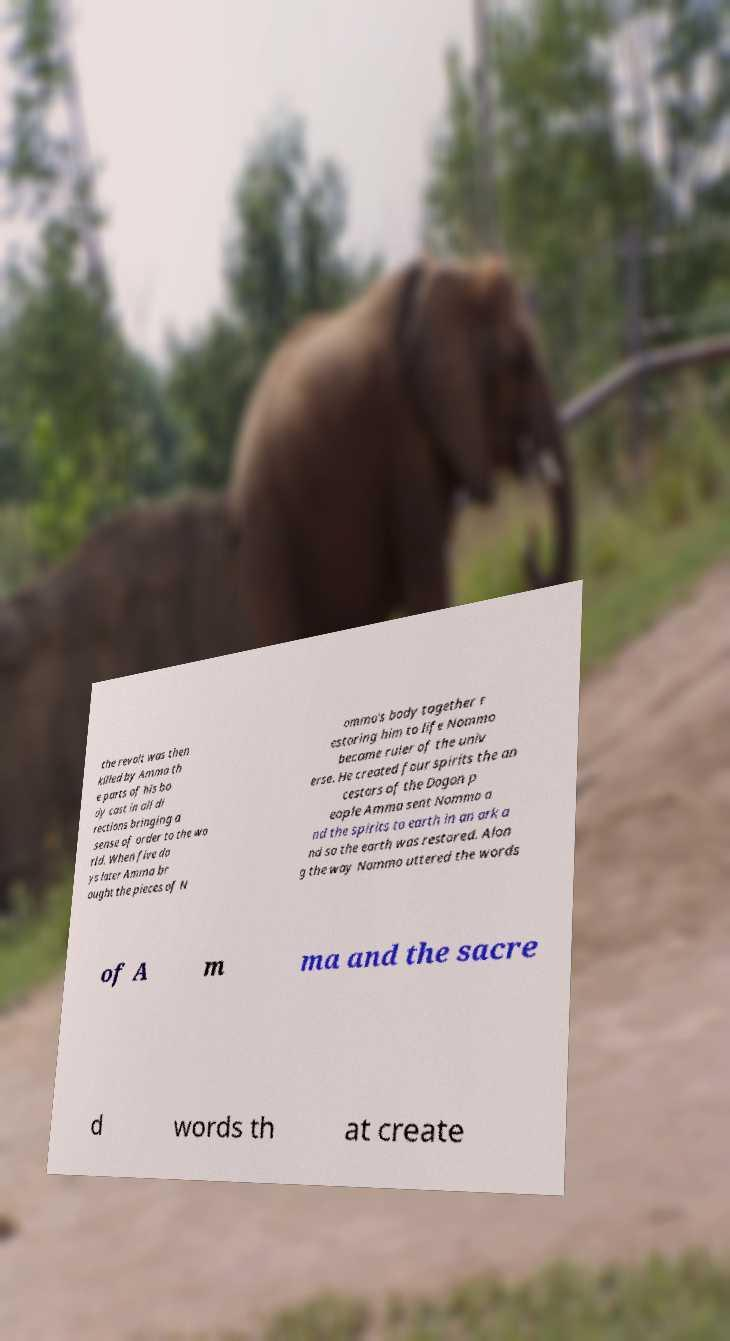Can you read and provide the text displayed in the image?This photo seems to have some interesting text. Can you extract and type it out for me? the revolt was then killed by Amma th e parts of his bo dy cast in all di rections bringing a sense of order to the wo rld. When five da ys later Amma br ought the pieces of N ommo's body together r estoring him to life Nommo became ruler of the univ erse. He created four spirits the an cestors of the Dogon p eople Amma sent Nommo a nd the spirits to earth in an ark a nd so the earth was restored. Alon g the way Nommo uttered the words of A m ma and the sacre d words th at create 